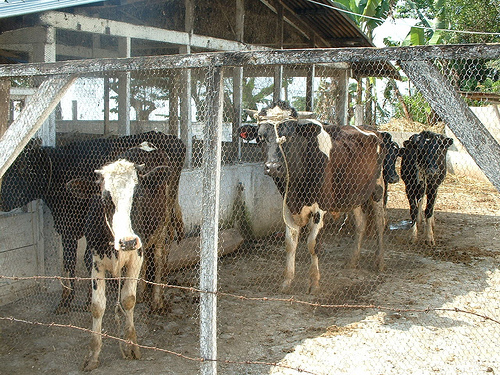The nearby cow to the left who is looking at the camera wears what color down his face?
A. black
B. gray
C. white
D. brown
Answer with the option's letter from the given choices directly. C 